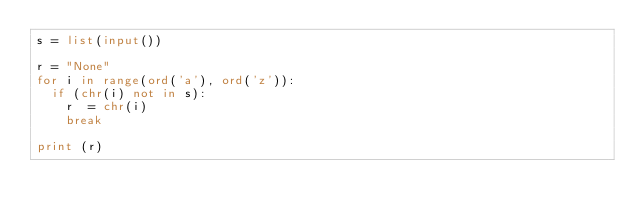Convert code to text. <code><loc_0><loc_0><loc_500><loc_500><_Python_>s = list(input())

r = "None"
for i in range(ord('a'), ord('z')):
	if (chr(i) not in s):
		r  = chr(i)
		break

print (r)

</code> 